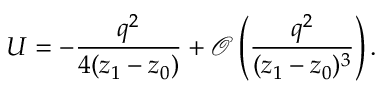Convert formula to latex. <formula><loc_0><loc_0><loc_500><loc_500>U = - \frac { q ^ { 2 } } { 4 ( z _ { 1 } - z _ { 0 } ) } + \mathcal { O } \left ( \frac { q ^ { 2 } } { ( z _ { 1 } - z _ { 0 } ) ^ { 3 } } \right ) .</formula> 